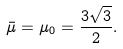<formula> <loc_0><loc_0><loc_500><loc_500>\bar { \mu } = \mu _ { 0 } = \frac { 3 \sqrt { 3 } } { 2 } .</formula> 